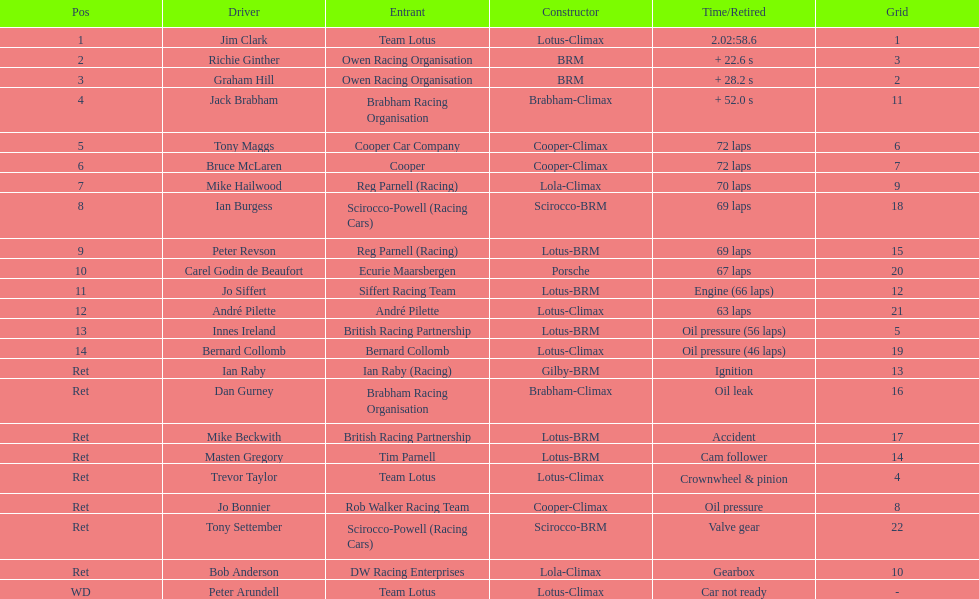What common problem did both bernard collomb and innes ireland encounter? Oil pressure. 